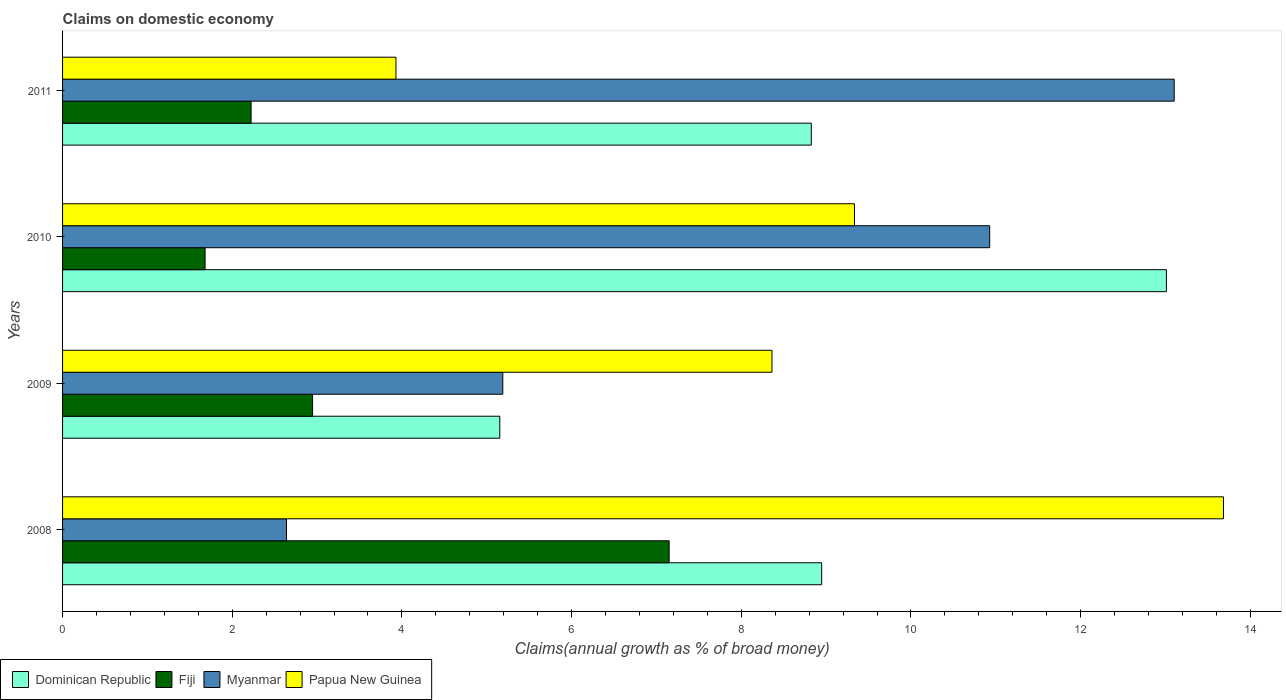How many different coloured bars are there?
Provide a short and direct response. 4. How many groups of bars are there?
Keep it short and to the point. 4. Are the number of bars on each tick of the Y-axis equal?
Your answer should be very brief. Yes. How many bars are there on the 1st tick from the top?
Offer a terse response. 4. In how many cases, is the number of bars for a given year not equal to the number of legend labels?
Your response must be concise. 0. What is the percentage of broad money claimed on domestic economy in Fiji in 2010?
Provide a succinct answer. 1.68. Across all years, what is the maximum percentage of broad money claimed on domestic economy in Myanmar?
Your response must be concise. 13.1. Across all years, what is the minimum percentage of broad money claimed on domestic economy in Fiji?
Ensure brevity in your answer.  1.68. What is the total percentage of broad money claimed on domestic economy in Papua New Guinea in the graph?
Offer a very short reply. 35.31. What is the difference between the percentage of broad money claimed on domestic economy in Myanmar in 2010 and that in 2011?
Keep it short and to the point. -2.17. What is the difference between the percentage of broad money claimed on domestic economy in Dominican Republic in 2011 and the percentage of broad money claimed on domestic economy in Fiji in 2008?
Keep it short and to the point. 1.68. What is the average percentage of broad money claimed on domestic economy in Myanmar per year?
Ensure brevity in your answer.  7.96. In the year 2008, what is the difference between the percentage of broad money claimed on domestic economy in Dominican Republic and percentage of broad money claimed on domestic economy in Fiji?
Offer a very short reply. 1.8. In how many years, is the percentage of broad money claimed on domestic economy in Dominican Republic greater than 13.2 %?
Your response must be concise. 0. What is the ratio of the percentage of broad money claimed on domestic economy in Myanmar in 2008 to that in 2011?
Your answer should be compact. 0.2. Is the percentage of broad money claimed on domestic economy in Dominican Republic in 2010 less than that in 2011?
Provide a succinct answer. No. Is the difference between the percentage of broad money claimed on domestic economy in Dominican Republic in 2008 and 2011 greater than the difference between the percentage of broad money claimed on domestic economy in Fiji in 2008 and 2011?
Provide a succinct answer. No. What is the difference between the highest and the second highest percentage of broad money claimed on domestic economy in Fiji?
Your answer should be compact. 4.2. What is the difference between the highest and the lowest percentage of broad money claimed on domestic economy in Fiji?
Make the answer very short. 5.47. In how many years, is the percentage of broad money claimed on domestic economy in Fiji greater than the average percentage of broad money claimed on domestic economy in Fiji taken over all years?
Provide a succinct answer. 1. Is the sum of the percentage of broad money claimed on domestic economy in Dominican Republic in 2009 and 2010 greater than the maximum percentage of broad money claimed on domestic economy in Papua New Guinea across all years?
Offer a terse response. Yes. Is it the case that in every year, the sum of the percentage of broad money claimed on domestic economy in Fiji and percentage of broad money claimed on domestic economy in Dominican Republic is greater than the sum of percentage of broad money claimed on domestic economy in Papua New Guinea and percentage of broad money claimed on domestic economy in Myanmar?
Make the answer very short. No. What does the 1st bar from the top in 2011 represents?
Keep it short and to the point. Papua New Guinea. What does the 2nd bar from the bottom in 2009 represents?
Make the answer very short. Fiji. Are all the bars in the graph horizontal?
Your answer should be compact. Yes. How many years are there in the graph?
Provide a short and direct response. 4. What is the difference between two consecutive major ticks on the X-axis?
Provide a succinct answer. 2. Does the graph contain any zero values?
Ensure brevity in your answer.  No. Does the graph contain grids?
Your answer should be compact. No. Where does the legend appear in the graph?
Offer a very short reply. Bottom left. How are the legend labels stacked?
Ensure brevity in your answer.  Horizontal. What is the title of the graph?
Provide a short and direct response. Claims on domestic economy. What is the label or title of the X-axis?
Keep it short and to the point. Claims(annual growth as % of broad money). What is the label or title of the Y-axis?
Provide a short and direct response. Years. What is the Claims(annual growth as % of broad money) of Dominican Republic in 2008?
Your response must be concise. 8.95. What is the Claims(annual growth as % of broad money) in Fiji in 2008?
Offer a terse response. 7.15. What is the Claims(annual growth as % of broad money) in Myanmar in 2008?
Provide a short and direct response. 2.64. What is the Claims(annual growth as % of broad money) in Papua New Guinea in 2008?
Ensure brevity in your answer.  13.68. What is the Claims(annual growth as % of broad money) of Dominican Republic in 2009?
Provide a succinct answer. 5.15. What is the Claims(annual growth as % of broad money) of Fiji in 2009?
Ensure brevity in your answer.  2.95. What is the Claims(annual growth as % of broad money) in Myanmar in 2009?
Provide a short and direct response. 5.19. What is the Claims(annual growth as % of broad money) of Papua New Guinea in 2009?
Offer a terse response. 8.36. What is the Claims(annual growth as % of broad money) of Dominican Republic in 2010?
Make the answer very short. 13.01. What is the Claims(annual growth as % of broad money) of Fiji in 2010?
Provide a succinct answer. 1.68. What is the Claims(annual growth as % of broad money) in Myanmar in 2010?
Your answer should be compact. 10.93. What is the Claims(annual growth as % of broad money) in Papua New Guinea in 2010?
Offer a very short reply. 9.33. What is the Claims(annual growth as % of broad money) of Dominican Republic in 2011?
Your answer should be very brief. 8.83. What is the Claims(annual growth as % of broad money) of Fiji in 2011?
Your response must be concise. 2.22. What is the Claims(annual growth as % of broad money) in Myanmar in 2011?
Keep it short and to the point. 13.1. What is the Claims(annual growth as % of broad money) in Papua New Guinea in 2011?
Give a very brief answer. 3.93. Across all years, what is the maximum Claims(annual growth as % of broad money) in Dominican Republic?
Ensure brevity in your answer.  13.01. Across all years, what is the maximum Claims(annual growth as % of broad money) of Fiji?
Offer a terse response. 7.15. Across all years, what is the maximum Claims(annual growth as % of broad money) in Myanmar?
Your answer should be compact. 13.1. Across all years, what is the maximum Claims(annual growth as % of broad money) of Papua New Guinea?
Your answer should be compact. 13.68. Across all years, what is the minimum Claims(annual growth as % of broad money) in Dominican Republic?
Ensure brevity in your answer.  5.15. Across all years, what is the minimum Claims(annual growth as % of broad money) in Fiji?
Offer a very short reply. 1.68. Across all years, what is the minimum Claims(annual growth as % of broad money) of Myanmar?
Keep it short and to the point. 2.64. Across all years, what is the minimum Claims(annual growth as % of broad money) of Papua New Guinea?
Your answer should be very brief. 3.93. What is the total Claims(annual growth as % of broad money) in Dominican Republic in the graph?
Your answer should be compact. 35.94. What is the total Claims(annual growth as % of broad money) of Fiji in the graph?
Offer a very short reply. 14. What is the total Claims(annual growth as % of broad money) in Myanmar in the graph?
Offer a terse response. 31.86. What is the total Claims(annual growth as % of broad money) in Papua New Guinea in the graph?
Provide a short and direct response. 35.31. What is the difference between the Claims(annual growth as % of broad money) in Dominican Republic in 2008 and that in 2009?
Make the answer very short. 3.79. What is the difference between the Claims(annual growth as % of broad money) of Fiji in 2008 and that in 2009?
Your response must be concise. 4.2. What is the difference between the Claims(annual growth as % of broad money) in Myanmar in 2008 and that in 2009?
Provide a succinct answer. -2.55. What is the difference between the Claims(annual growth as % of broad money) of Papua New Guinea in 2008 and that in 2009?
Provide a short and direct response. 5.32. What is the difference between the Claims(annual growth as % of broad money) of Dominican Republic in 2008 and that in 2010?
Offer a very short reply. -4.06. What is the difference between the Claims(annual growth as % of broad money) of Fiji in 2008 and that in 2010?
Keep it short and to the point. 5.47. What is the difference between the Claims(annual growth as % of broad money) of Myanmar in 2008 and that in 2010?
Your response must be concise. -8.29. What is the difference between the Claims(annual growth as % of broad money) of Papua New Guinea in 2008 and that in 2010?
Offer a very short reply. 4.35. What is the difference between the Claims(annual growth as % of broad money) of Dominican Republic in 2008 and that in 2011?
Your response must be concise. 0.12. What is the difference between the Claims(annual growth as % of broad money) of Fiji in 2008 and that in 2011?
Give a very brief answer. 4.93. What is the difference between the Claims(annual growth as % of broad money) of Myanmar in 2008 and that in 2011?
Your response must be concise. -10.46. What is the difference between the Claims(annual growth as % of broad money) of Papua New Guinea in 2008 and that in 2011?
Make the answer very short. 9.75. What is the difference between the Claims(annual growth as % of broad money) in Dominican Republic in 2009 and that in 2010?
Provide a short and direct response. -7.86. What is the difference between the Claims(annual growth as % of broad money) of Fiji in 2009 and that in 2010?
Give a very brief answer. 1.27. What is the difference between the Claims(annual growth as % of broad money) of Myanmar in 2009 and that in 2010?
Provide a short and direct response. -5.74. What is the difference between the Claims(annual growth as % of broad money) of Papua New Guinea in 2009 and that in 2010?
Keep it short and to the point. -0.97. What is the difference between the Claims(annual growth as % of broad money) in Dominican Republic in 2009 and that in 2011?
Keep it short and to the point. -3.67. What is the difference between the Claims(annual growth as % of broad money) in Fiji in 2009 and that in 2011?
Provide a succinct answer. 0.72. What is the difference between the Claims(annual growth as % of broad money) of Myanmar in 2009 and that in 2011?
Provide a succinct answer. -7.91. What is the difference between the Claims(annual growth as % of broad money) in Papua New Guinea in 2009 and that in 2011?
Ensure brevity in your answer.  4.43. What is the difference between the Claims(annual growth as % of broad money) in Dominican Republic in 2010 and that in 2011?
Ensure brevity in your answer.  4.19. What is the difference between the Claims(annual growth as % of broad money) of Fiji in 2010 and that in 2011?
Give a very brief answer. -0.54. What is the difference between the Claims(annual growth as % of broad money) of Myanmar in 2010 and that in 2011?
Provide a succinct answer. -2.17. What is the difference between the Claims(annual growth as % of broad money) in Papua New Guinea in 2010 and that in 2011?
Make the answer very short. 5.4. What is the difference between the Claims(annual growth as % of broad money) in Dominican Republic in 2008 and the Claims(annual growth as % of broad money) in Fiji in 2009?
Make the answer very short. 6. What is the difference between the Claims(annual growth as % of broad money) in Dominican Republic in 2008 and the Claims(annual growth as % of broad money) in Myanmar in 2009?
Keep it short and to the point. 3.76. What is the difference between the Claims(annual growth as % of broad money) in Dominican Republic in 2008 and the Claims(annual growth as % of broad money) in Papua New Guinea in 2009?
Provide a short and direct response. 0.59. What is the difference between the Claims(annual growth as % of broad money) of Fiji in 2008 and the Claims(annual growth as % of broad money) of Myanmar in 2009?
Offer a very short reply. 1.96. What is the difference between the Claims(annual growth as % of broad money) of Fiji in 2008 and the Claims(annual growth as % of broad money) of Papua New Guinea in 2009?
Your answer should be very brief. -1.21. What is the difference between the Claims(annual growth as % of broad money) of Myanmar in 2008 and the Claims(annual growth as % of broad money) of Papua New Guinea in 2009?
Offer a terse response. -5.72. What is the difference between the Claims(annual growth as % of broad money) in Dominican Republic in 2008 and the Claims(annual growth as % of broad money) in Fiji in 2010?
Offer a terse response. 7.27. What is the difference between the Claims(annual growth as % of broad money) in Dominican Republic in 2008 and the Claims(annual growth as % of broad money) in Myanmar in 2010?
Ensure brevity in your answer.  -1.98. What is the difference between the Claims(annual growth as % of broad money) in Dominican Republic in 2008 and the Claims(annual growth as % of broad money) in Papua New Guinea in 2010?
Make the answer very short. -0.39. What is the difference between the Claims(annual growth as % of broad money) of Fiji in 2008 and the Claims(annual growth as % of broad money) of Myanmar in 2010?
Give a very brief answer. -3.78. What is the difference between the Claims(annual growth as % of broad money) in Fiji in 2008 and the Claims(annual growth as % of broad money) in Papua New Guinea in 2010?
Your response must be concise. -2.18. What is the difference between the Claims(annual growth as % of broad money) of Myanmar in 2008 and the Claims(annual growth as % of broad money) of Papua New Guinea in 2010?
Give a very brief answer. -6.7. What is the difference between the Claims(annual growth as % of broad money) of Dominican Republic in 2008 and the Claims(annual growth as % of broad money) of Fiji in 2011?
Your answer should be compact. 6.73. What is the difference between the Claims(annual growth as % of broad money) in Dominican Republic in 2008 and the Claims(annual growth as % of broad money) in Myanmar in 2011?
Keep it short and to the point. -4.16. What is the difference between the Claims(annual growth as % of broad money) in Dominican Republic in 2008 and the Claims(annual growth as % of broad money) in Papua New Guinea in 2011?
Keep it short and to the point. 5.02. What is the difference between the Claims(annual growth as % of broad money) of Fiji in 2008 and the Claims(annual growth as % of broad money) of Myanmar in 2011?
Provide a short and direct response. -5.95. What is the difference between the Claims(annual growth as % of broad money) of Fiji in 2008 and the Claims(annual growth as % of broad money) of Papua New Guinea in 2011?
Ensure brevity in your answer.  3.22. What is the difference between the Claims(annual growth as % of broad money) in Myanmar in 2008 and the Claims(annual growth as % of broad money) in Papua New Guinea in 2011?
Give a very brief answer. -1.29. What is the difference between the Claims(annual growth as % of broad money) of Dominican Republic in 2009 and the Claims(annual growth as % of broad money) of Fiji in 2010?
Give a very brief answer. 3.47. What is the difference between the Claims(annual growth as % of broad money) in Dominican Republic in 2009 and the Claims(annual growth as % of broad money) in Myanmar in 2010?
Your answer should be compact. -5.77. What is the difference between the Claims(annual growth as % of broad money) in Dominican Republic in 2009 and the Claims(annual growth as % of broad money) in Papua New Guinea in 2010?
Give a very brief answer. -4.18. What is the difference between the Claims(annual growth as % of broad money) of Fiji in 2009 and the Claims(annual growth as % of broad money) of Myanmar in 2010?
Provide a succinct answer. -7.98. What is the difference between the Claims(annual growth as % of broad money) in Fiji in 2009 and the Claims(annual growth as % of broad money) in Papua New Guinea in 2010?
Keep it short and to the point. -6.39. What is the difference between the Claims(annual growth as % of broad money) in Myanmar in 2009 and the Claims(annual growth as % of broad money) in Papua New Guinea in 2010?
Your answer should be very brief. -4.15. What is the difference between the Claims(annual growth as % of broad money) in Dominican Republic in 2009 and the Claims(annual growth as % of broad money) in Fiji in 2011?
Ensure brevity in your answer.  2.93. What is the difference between the Claims(annual growth as % of broad money) of Dominican Republic in 2009 and the Claims(annual growth as % of broad money) of Myanmar in 2011?
Provide a succinct answer. -7.95. What is the difference between the Claims(annual growth as % of broad money) of Dominican Republic in 2009 and the Claims(annual growth as % of broad money) of Papua New Guinea in 2011?
Provide a succinct answer. 1.22. What is the difference between the Claims(annual growth as % of broad money) in Fiji in 2009 and the Claims(annual growth as % of broad money) in Myanmar in 2011?
Keep it short and to the point. -10.16. What is the difference between the Claims(annual growth as % of broad money) in Fiji in 2009 and the Claims(annual growth as % of broad money) in Papua New Guinea in 2011?
Keep it short and to the point. -0.98. What is the difference between the Claims(annual growth as % of broad money) of Myanmar in 2009 and the Claims(annual growth as % of broad money) of Papua New Guinea in 2011?
Your answer should be compact. 1.26. What is the difference between the Claims(annual growth as % of broad money) in Dominican Republic in 2010 and the Claims(annual growth as % of broad money) in Fiji in 2011?
Offer a very short reply. 10.79. What is the difference between the Claims(annual growth as % of broad money) of Dominican Republic in 2010 and the Claims(annual growth as % of broad money) of Myanmar in 2011?
Offer a terse response. -0.09. What is the difference between the Claims(annual growth as % of broad money) in Dominican Republic in 2010 and the Claims(annual growth as % of broad money) in Papua New Guinea in 2011?
Offer a terse response. 9.08. What is the difference between the Claims(annual growth as % of broad money) in Fiji in 2010 and the Claims(annual growth as % of broad money) in Myanmar in 2011?
Your response must be concise. -11.42. What is the difference between the Claims(annual growth as % of broad money) in Fiji in 2010 and the Claims(annual growth as % of broad money) in Papua New Guinea in 2011?
Offer a terse response. -2.25. What is the difference between the Claims(annual growth as % of broad money) of Myanmar in 2010 and the Claims(annual growth as % of broad money) of Papua New Guinea in 2011?
Your answer should be compact. 7. What is the average Claims(annual growth as % of broad money) in Dominican Republic per year?
Provide a short and direct response. 8.98. What is the average Claims(annual growth as % of broad money) of Fiji per year?
Your response must be concise. 3.5. What is the average Claims(annual growth as % of broad money) in Myanmar per year?
Give a very brief answer. 7.96. What is the average Claims(annual growth as % of broad money) of Papua New Guinea per year?
Offer a terse response. 8.83. In the year 2008, what is the difference between the Claims(annual growth as % of broad money) of Dominican Republic and Claims(annual growth as % of broad money) of Fiji?
Ensure brevity in your answer.  1.8. In the year 2008, what is the difference between the Claims(annual growth as % of broad money) in Dominican Republic and Claims(annual growth as % of broad money) in Myanmar?
Ensure brevity in your answer.  6.31. In the year 2008, what is the difference between the Claims(annual growth as % of broad money) of Dominican Republic and Claims(annual growth as % of broad money) of Papua New Guinea?
Your response must be concise. -4.74. In the year 2008, what is the difference between the Claims(annual growth as % of broad money) of Fiji and Claims(annual growth as % of broad money) of Myanmar?
Make the answer very short. 4.51. In the year 2008, what is the difference between the Claims(annual growth as % of broad money) of Fiji and Claims(annual growth as % of broad money) of Papua New Guinea?
Give a very brief answer. -6.53. In the year 2008, what is the difference between the Claims(annual growth as % of broad money) of Myanmar and Claims(annual growth as % of broad money) of Papua New Guinea?
Offer a terse response. -11.04. In the year 2009, what is the difference between the Claims(annual growth as % of broad money) of Dominican Republic and Claims(annual growth as % of broad money) of Fiji?
Provide a succinct answer. 2.21. In the year 2009, what is the difference between the Claims(annual growth as % of broad money) in Dominican Republic and Claims(annual growth as % of broad money) in Myanmar?
Ensure brevity in your answer.  -0.04. In the year 2009, what is the difference between the Claims(annual growth as % of broad money) of Dominican Republic and Claims(annual growth as % of broad money) of Papua New Guinea?
Ensure brevity in your answer.  -3.21. In the year 2009, what is the difference between the Claims(annual growth as % of broad money) of Fiji and Claims(annual growth as % of broad money) of Myanmar?
Keep it short and to the point. -2.24. In the year 2009, what is the difference between the Claims(annual growth as % of broad money) in Fiji and Claims(annual growth as % of broad money) in Papua New Guinea?
Your answer should be very brief. -5.41. In the year 2009, what is the difference between the Claims(annual growth as % of broad money) in Myanmar and Claims(annual growth as % of broad money) in Papua New Guinea?
Offer a terse response. -3.17. In the year 2010, what is the difference between the Claims(annual growth as % of broad money) of Dominican Republic and Claims(annual growth as % of broad money) of Fiji?
Provide a short and direct response. 11.33. In the year 2010, what is the difference between the Claims(annual growth as % of broad money) in Dominican Republic and Claims(annual growth as % of broad money) in Myanmar?
Offer a very short reply. 2.08. In the year 2010, what is the difference between the Claims(annual growth as % of broad money) of Dominican Republic and Claims(annual growth as % of broad money) of Papua New Guinea?
Offer a terse response. 3.68. In the year 2010, what is the difference between the Claims(annual growth as % of broad money) in Fiji and Claims(annual growth as % of broad money) in Myanmar?
Keep it short and to the point. -9.25. In the year 2010, what is the difference between the Claims(annual growth as % of broad money) in Fiji and Claims(annual growth as % of broad money) in Papua New Guinea?
Keep it short and to the point. -7.65. In the year 2010, what is the difference between the Claims(annual growth as % of broad money) of Myanmar and Claims(annual growth as % of broad money) of Papua New Guinea?
Make the answer very short. 1.59. In the year 2011, what is the difference between the Claims(annual growth as % of broad money) of Dominican Republic and Claims(annual growth as % of broad money) of Fiji?
Your answer should be very brief. 6.6. In the year 2011, what is the difference between the Claims(annual growth as % of broad money) in Dominican Republic and Claims(annual growth as % of broad money) in Myanmar?
Make the answer very short. -4.28. In the year 2011, what is the difference between the Claims(annual growth as % of broad money) of Dominican Republic and Claims(annual growth as % of broad money) of Papua New Guinea?
Provide a succinct answer. 4.9. In the year 2011, what is the difference between the Claims(annual growth as % of broad money) of Fiji and Claims(annual growth as % of broad money) of Myanmar?
Your answer should be very brief. -10.88. In the year 2011, what is the difference between the Claims(annual growth as % of broad money) in Fiji and Claims(annual growth as % of broad money) in Papua New Guinea?
Provide a short and direct response. -1.71. In the year 2011, what is the difference between the Claims(annual growth as % of broad money) of Myanmar and Claims(annual growth as % of broad money) of Papua New Guinea?
Your answer should be very brief. 9.17. What is the ratio of the Claims(annual growth as % of broad money) of Dominican Republic in 2008 to that in 2009?
Give a very brief answer. 1.74. What is the ratio of the Claims(annual growth as % of broad money) of Fiji in 2008 to that in 2009?
Your response must be concise. 2.43. What is the ratio of the Claims(annual growth as % of broad money) in Myanmar in 2008 to that in 2009?
Give a very brief answer. 0.51. What is the ratio of the Claims(annual growth as % of broad money) in Papua New Guinea in 2008 to that in 2009?
Ensure brevity in your answer.  1.64. What is the ratio of the Claims(annual growth as % of broad money) of Dominican Republic in 2008 to that in 2010?
Give a very brief answer. 0.69. What is the ratio of the Claims(annual growth as % of broad money) of Fiji in 2008 to that in 2010?
Give a very brief answer. 4.26. What is the ratio of the Claims(annual growth as % of broad money) in Myanmar in 2008 to that in 2010?
Offer a terse response. 0.24. What is the ratio of the Claims(annual growth as % of broad money) in Papua New Guinea in 2008 to that in 2010?
Provide a short and direct response. 1.47. What is the ratio of the Claims(annual growth as % of broad money) of Dominican Republic in 2008 to that in 2011?
Offer a very short reply. 1.01. What is the ratio of the Claims(annual growth as % of broad money) in Fiji in 2008 to that in 2011?
Your answer should be very brief. 3.22. What is the ratio of the Claims(annual growth as % of broad money) of Myanmar in 2008 to that in 2011?
Provide a short and direct response. 0.2. What is the ratio of the Claims(annual growth as % of broad money) of Papua New Guinea in 2008 to that in 2011?
Provide a short and direct response. 3.48. What is the ratio of the Claims(annual growth as % of broad money) in Dominican Republic in 2009 to that in 2010?
Make the answer very short. 0.4. What is the ratio of the Claims(annual growth as % of broad money) in Fiji in 2009 to that in 2010?
Offer a very short reply. 1.75. What is the ratio of the Claims(annual growth as % of broad money) in Myanmar in 2009 to that in 2010?
Offer a terse response. 0.47. What is the ratio of the Claims(annual growth as % of broad money) of Papua New Guinea in 2009 to that in 2010?
Make the answer very short. 0.9. What is the ratio of the Claims(annual growth as % of broad money) of Dominican Republic in 2009 to that in 2011?
Make the answer very short. 0.58. What is the ratio of the Claims(annual growth as % of broad money) of Fiji in 2009 to that in 2011?
Your answer should be compact. 1.33. What is the ratio of the Claims(annual growth as % of broad money) of Myanmar in 2009 to that in 2011?
Keep it short and to the point. 0.4. What is the ratio of the Claims(annual growth as % of broad money) of Papua New Guinea in 2009 to that in 2011?
Offer a terse response. 2.13. What is the ratio of the Claims(annual growth as % of broad money) of Dominican Republic in 2010 to that in 2011?
Give a very brief answer. 1.47. What is the ratio of the Claims(annual growth as % of broad money) in Fiji in 2010 to that in 2011?
Offer a very short reply. 0.76. What is the ratio of the Claims(annual growth as % of broad money) in Myanmar in 2010 to that in 2011?
Your answer should be compact. 0.83. What is the ratio of the Claims(annual growth as % of broad money) of Papua New Guinea in 2010 to that in 2011?
Offer a terse response. 2.38. What is the difference between the highest and the second highest Claims(annual growth as % of broad money) in Dominican Republic?
Your response must be concise. 4.06. What is the difference between the highest and the second highest Claims(annual growth as % of broad money) in Fiji?
Ensure brevity in your answer.  4.2. What is the difference between the highest and the second highest Claims(annual growth as % of broad money) of Myanmar?
Your response must be concise. 2.17. What is the difference between the highest and the second highest Claims(annual growth as % of broad money) in Papua New Guinea?
Ensure brevity in your answer.  4.35. What is the difference between the highest and the lowest Claims(annual growth as % of broad money) in Dominican Republic?
Make the answer very short. 7.86. What is the difference between the highest and the lowest Claims(annual growth as % of broad money) in Fiji?
Offer a terse response. 5.47. What is the difference between the highest and the lowest Claims(annual growth as % of broad money) of Myanmar?
Provide a short and direct response. 10.46. What is the difference between the highest and the lowest Claims(annual growth as % of broad money) of Papua New Guinea?
Keep it short and to the point. 9.75. 